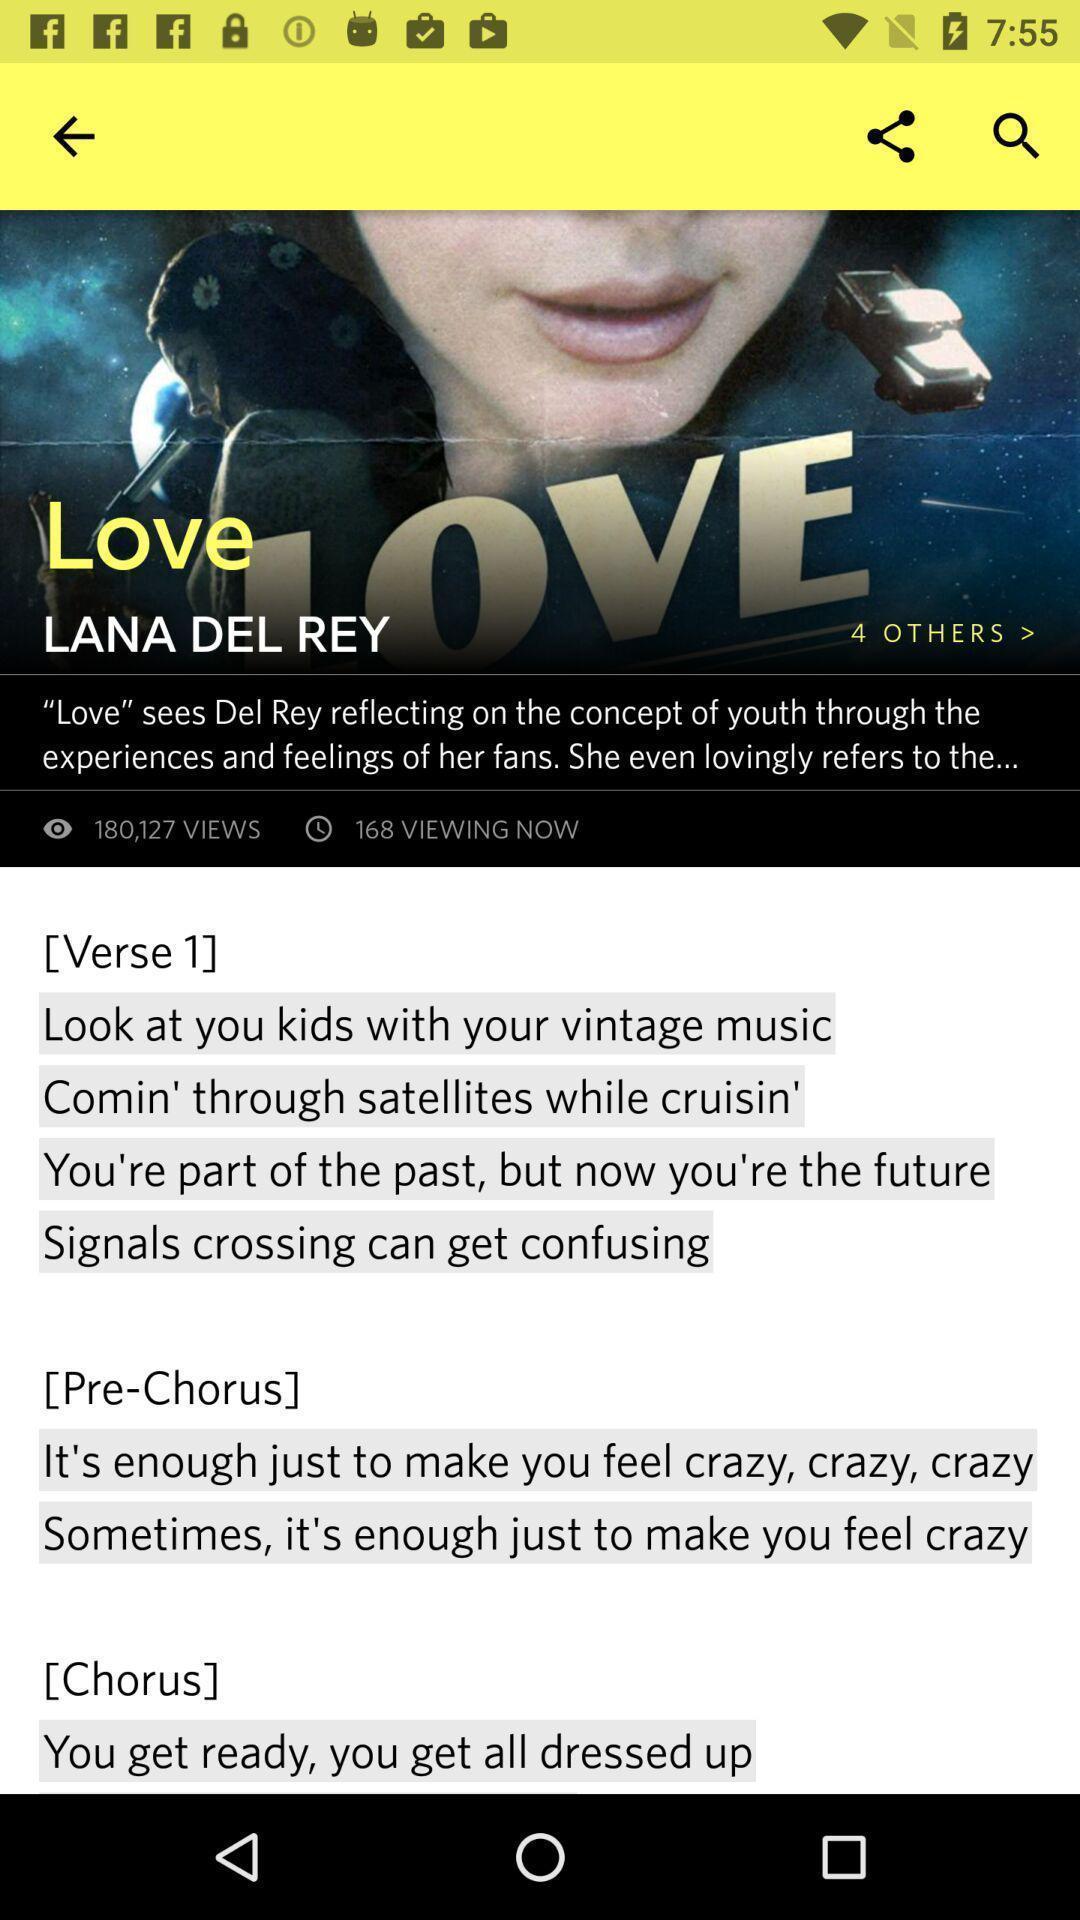Describe the key features of this screenshot. Song with lyrics is showing on the screen. 